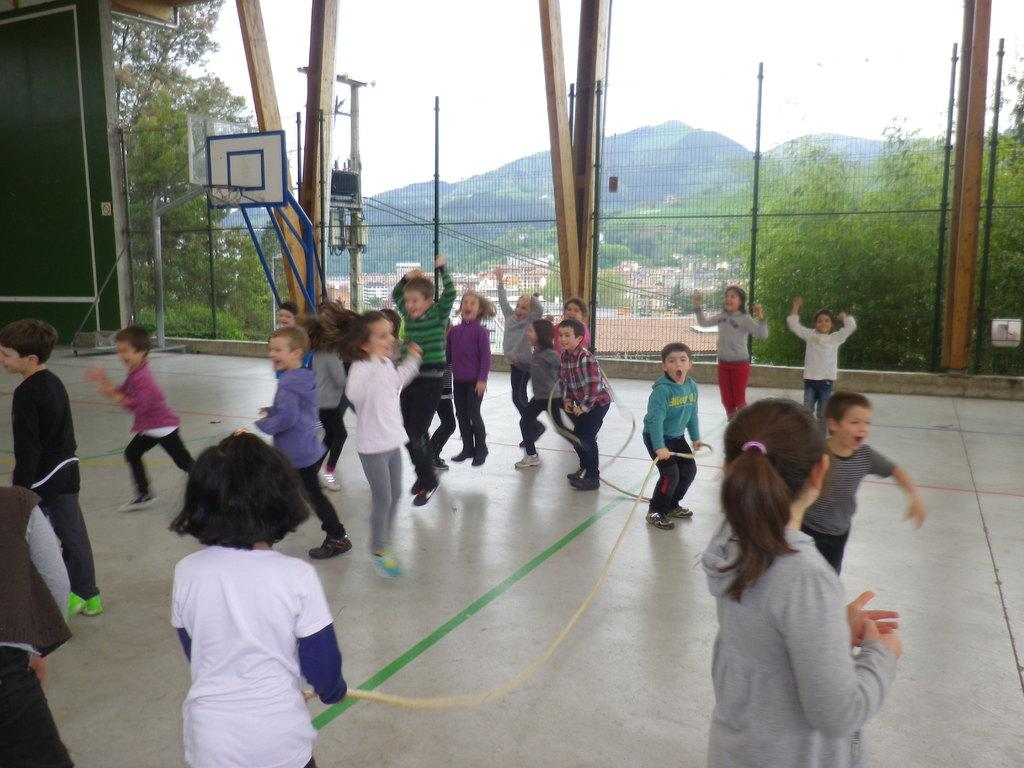What is the position of the child in the image? There is a child standing on the left side of the image. What is the child wearing? The child is wearing a white t-shirt. How many children are present in the image? There are other children in the image. What are the children doing in the image? The children are jumping and playing games. What is the purpose of the iron net in the image? The iron net is not mentioned to have a specific purpose in the image, but it is present. What can be seen outside the iron net? Trees are visible outside the iron net. How many fifths are visible in the image? There is no mention of a "fifth" in the image, so it cannot be counted. What type of bike can be seen in the image? There is no bike present in the image. 